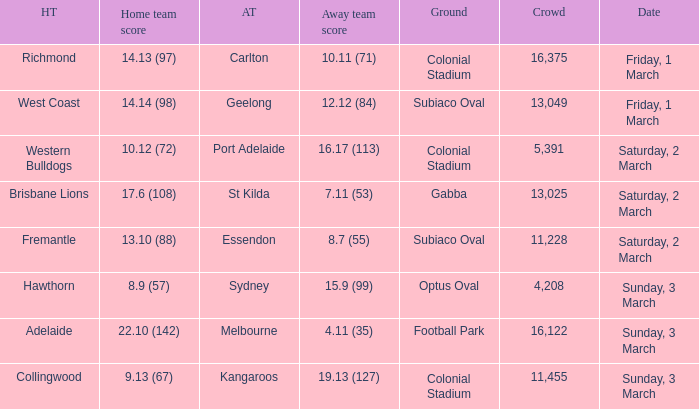What was the basis for the away team sydney? Optus Oval. 